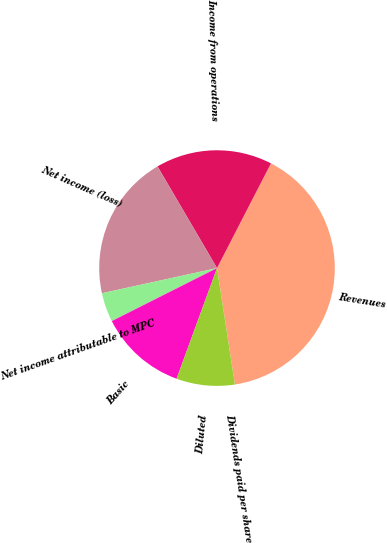<chart> <loc_0><loc_0><loc_500><loc_500><pie_chart><fcel>Revenues<fcel>Income from operations<fcel>Net income (loss)<fcel>Net income attributable to MPC<fcel>Basic<fcel>Diluted<fcel>Dividends paid per share<nl><fcel>40.0%<fcel>16.0%<fcel>20.0%<fcel>4.0%<fcel>12.0%<fcel>8.0%<fcel>0.0%<nl></chart> 